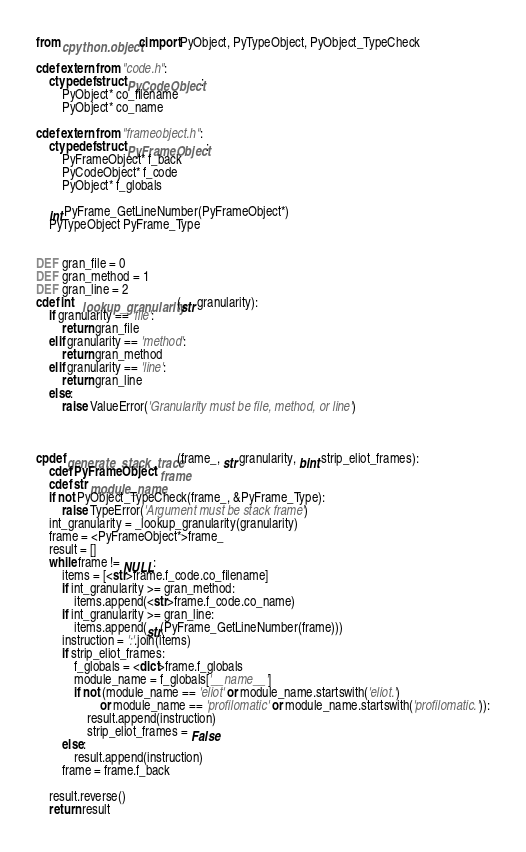Convert code to text. <code><loc_0><loc_0><loc_500><loc_500><_Cython_>from cpython.object cimport PyObject, PyTypeObject, PyObject_TypeCheck

cdef extern from "code.h":
    ctypedef struct PyCodeObject:
        PyObject* co_filename
        PyObject* co_name

cdef extern from "frameobject.h":
    ctypedef struct PyFrameObject:
        PyFrameObject* f_back
        PyCodeObject* f_code
        PyObject* f_globals

    int PyFrame_GetLineNumber(PyFrameObject*)
    PyTypeObject PyFrame_Type


DEF gran_file = 0
DEF gran_method = 1
DEF gran_line = 2
cdef int _lookup_granularity(str granularity):
    if granularity == 'file':
        return gran_file
    elif granularity == 'method':
        return gran_method
    elif granularity == 'line':
        return gran_line
    else:
        raise ValueError('Granularity must be file, method, or line')



cpdef generate_stack_trace(frame_, str granularity, bint strip_eliot_frames):
    cdef PyFrameObject* frame
    cdef str module_name
    if not PyObject_TypeCheck(frame_, &PyFrame_Type):
        raise TypeError('Argument must be stack frame')
    int_granularity = _lookup_granularity(granularity)
    frame = <PyFrameObject*>frame_
    result = []
    while frame != NULL:
        items = [<str>frame.f_code.co_filename]
        if int_granularity >= gran_method:
            items.append(<str>frame.f_code.co_name)
        if int_granularity >= gran_line:
            items.append(str(PyFrame_GetLineNumber(frame)))
        instruction = ':'.join(items)
        if strip_eliot_frames:
            f_globals = <dict>frame.f_globals
            module_name = f_globals['__name__']
            if not (module_name == 'eliot' or module_name.startswith('eliot.')
                    or module_name == 'profilomatic' or module_name.startswith('profilomatic.')):
                result.append(instruction)
                strip_eliot_frames = False
        else:
            result.append(instruction)
        frame = frame.f_back

    result.reverse()
    return result
</code> 